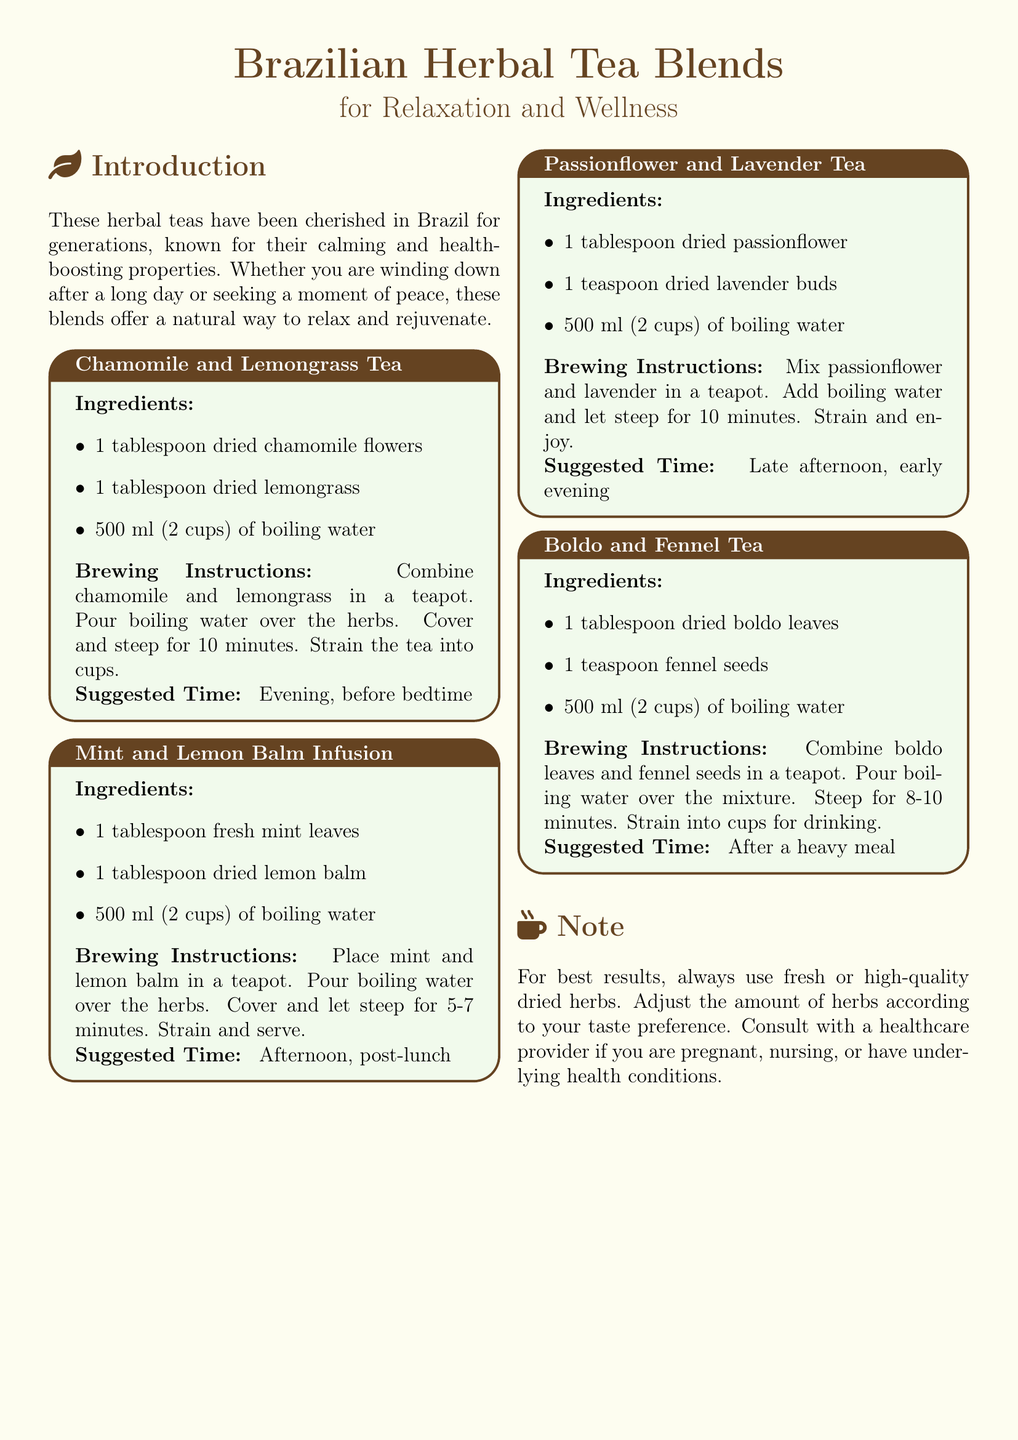what is the first tea recipe listed? The first tea recipe listed in the document is for "Chamomile and Lemongrass Tea."
Answer: Chamomile and Lemongrass Tea how long should you steep Mint and Lemon Balm Infusion? The steeping time for Mint and Lemon Balm Infusion is 5-7 minutes.
Answer: 5-7 minutes what is the suggested time for drinking Passionflower and Lavender Tea? The suggested time for drinking Passionflower and Lavender Tea is late afternoon, early evening.
Answer: Late afternoon, early evening how many tablespoons of dried boldo leaves are needed? The recipe for Boldo and Fennel Tea requires 1 tablespoon of dried boldo leaves.
Answer: 1 tablespoon which ingredient is common in both Chamomile and Lemongrass Tea and Passionflower and Lavender Tea? Both tea recipes include dried herbs that are meant for relaxation.
Answer: Dried herbs for relaxation what should you use for the best results in the tea recipes? For best results, you should use fresh or high-quality dried herbs.
Answer: Fresh or high-quality dried herbs how many cups of water is used in each recipe? Each recipe uses 500 ml of boiling water, which is equivalent to 2 cups.
Answer: 2 cups what is the purpose of these herbal teas according to the introduction? The purpose of these herbal teas is to promote relaxation and wellness.
Answer: Promote relaxation and wellness 